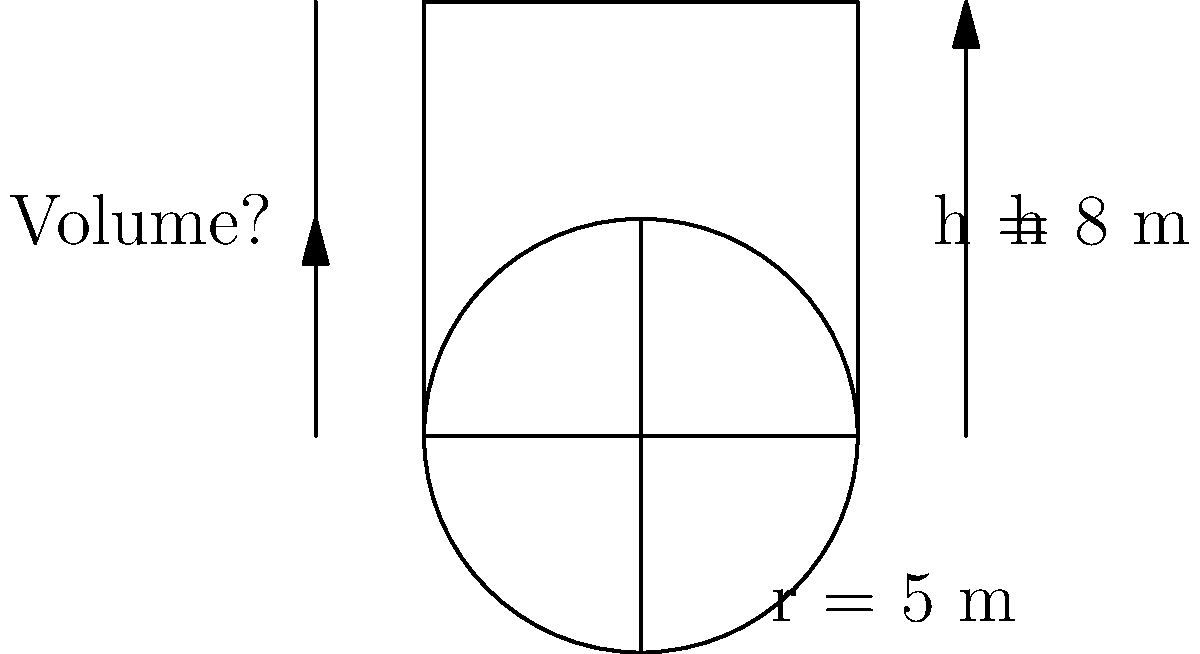As a store manager overseeing a renovation project, you need to estimate the amount of concrete required for a new cylindrical water tank. The tank has a radius of 5 meters and a height of 8 meters. What is the volume of concrete needed to construct this tank? (Use $\pi = 3.14$ for your calculations) To calculate the volume of a cylindrical tank, we use the formula:

$$V = \pi r^2 h$$

Where:
$V$ = volume
$r$ = radius
$h$ = height
$\pi$ = 3.14 (given)

Step 1: Identify the given values
$r = 5$ meters
$h = 8$ meters
$\pi = 3.14$

Step 2: Substitute these values into the formula
$$V = 3.14 \times 5^2 \times 8$$

Step 3: Calculate $5^2$
$$V = 3.14 \times 25 \times 8$$

Step 4: Multiply all the numbers
$$V = 628 \text{ cubic meters}$$

Therefore, the volume of concrete needed for the cylindrical water tank is 628 cubic meters.
Answer: 628 cubic meters 